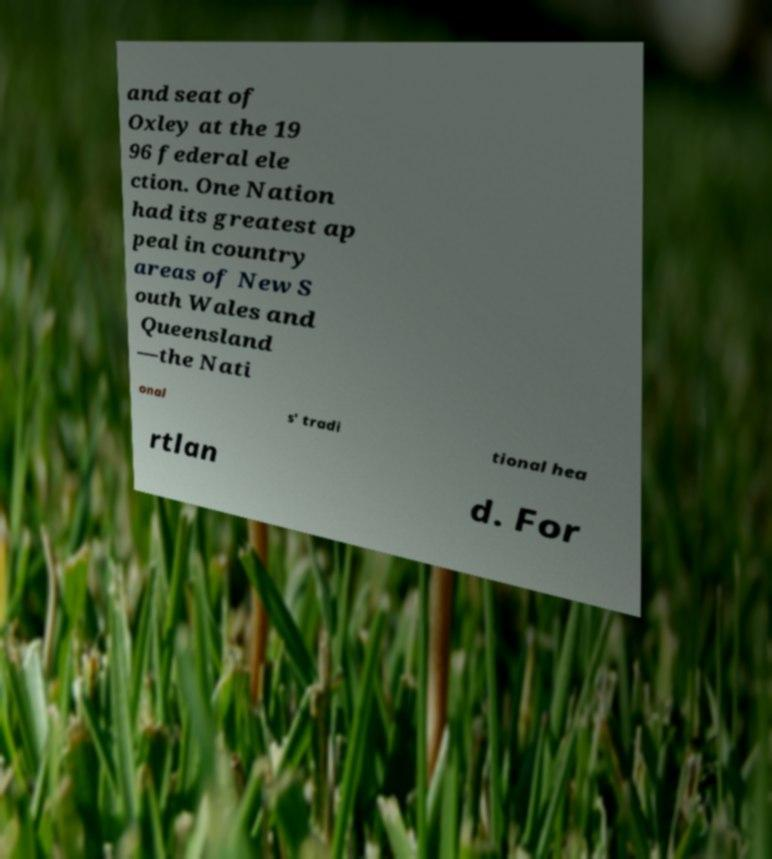What messages or text are displayed in this image? I need them in a readable, typed format. and seat of Oxley at the 19 96 federal ele ction. One Nation had its greatest ap peal in country areas of New S outh Wales and Queensland —the Nati onal s' tradi tional hea rtlan d. For 